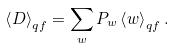Convert formula to latex. <formula><loc_0><loc_0><loc_500><loc_500>\left \langle D \right \rangle _ { q f } = \sum _ { w } P _ { w } \left \langle w \right \rangle _ { q f } .</formula> 